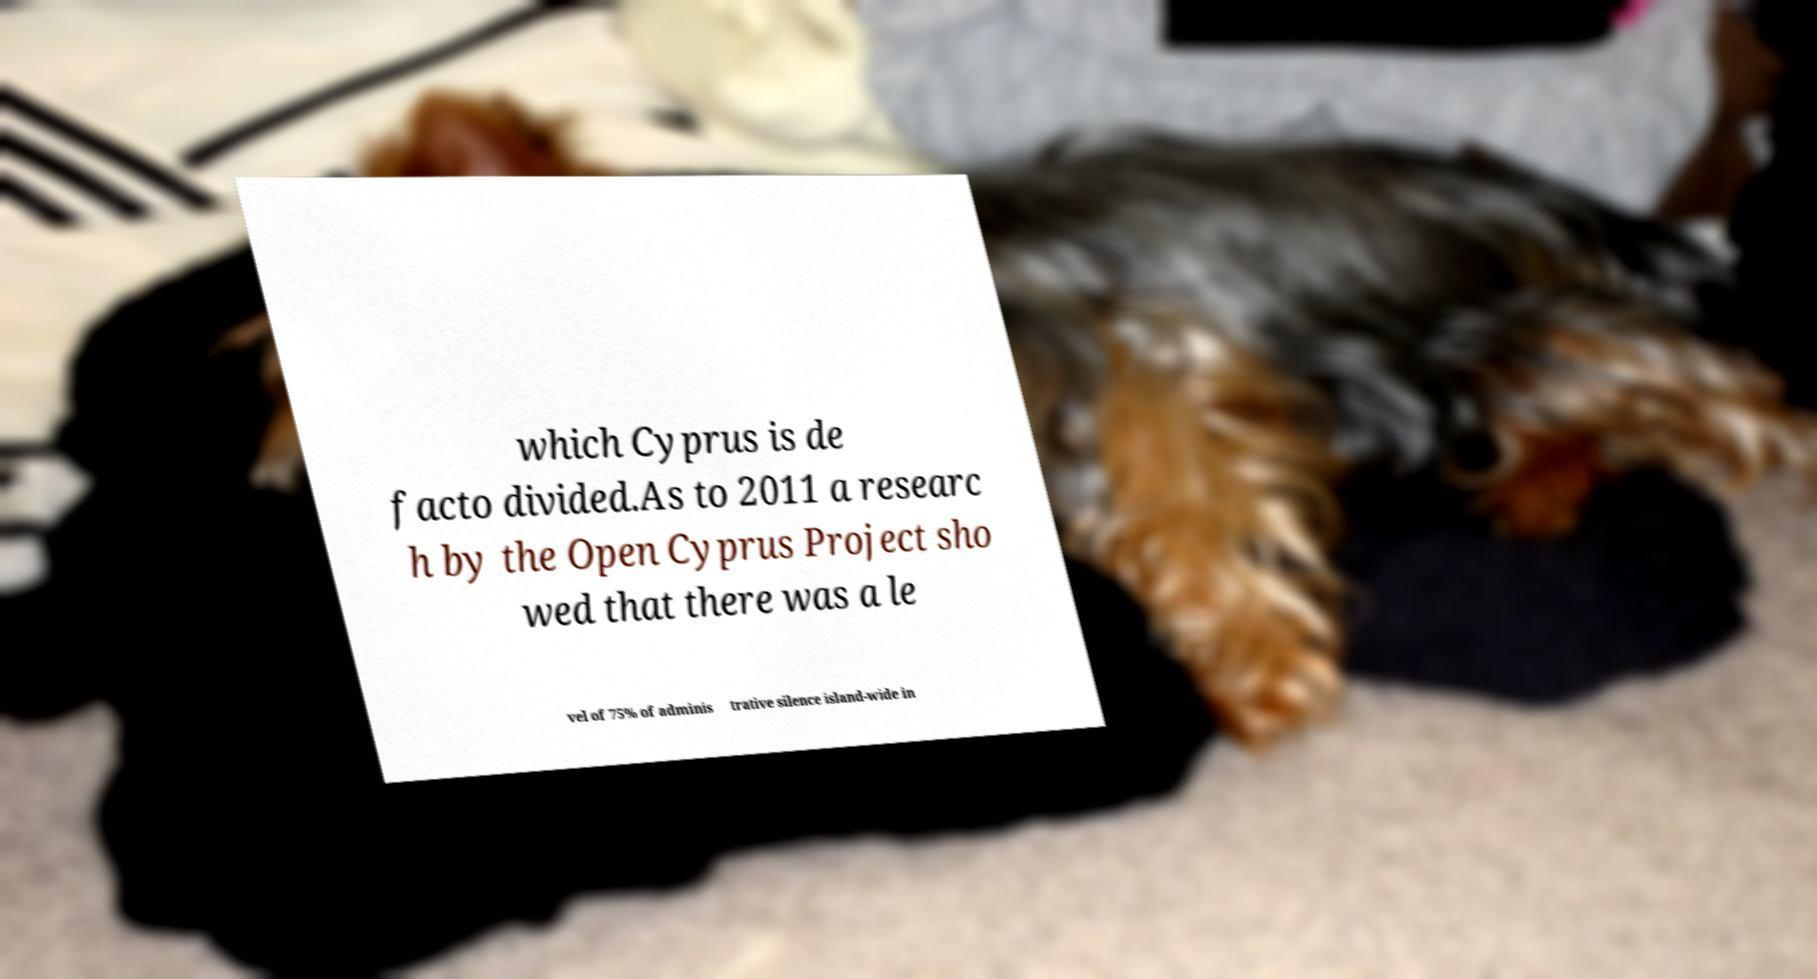Can you read and provide the text displayed in the image?This photo seems to have some interesting text. Can you extract and type it out for me? which Cyprus is de facto divided.As to 2011 a researc h by the Open Cyprus Project sho wed that there was a le vel of 75% of adminis trative silence island-wide in 